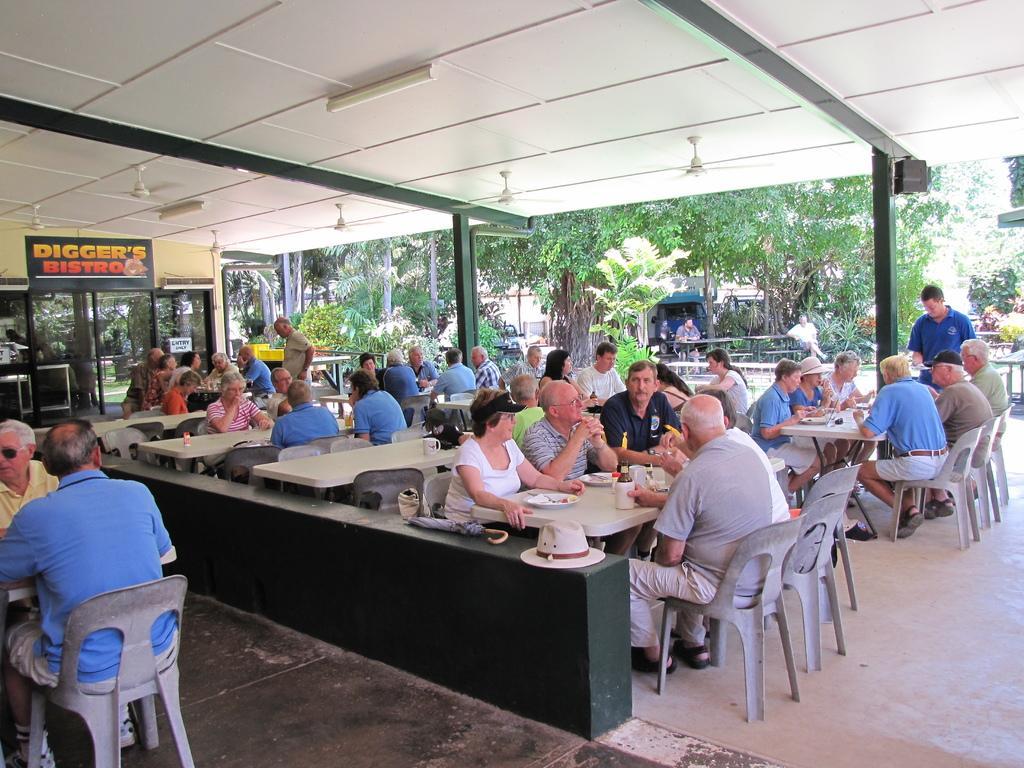In one or two sentences, can you explain what this image depicts? This image is clicked in a restaurant. There are many people in this image. In the background there are many trees and plants. To the left, there is a stall. There are many tables and chairs in the image. To the left, the man sitting is wearing a blue t-shirt. 